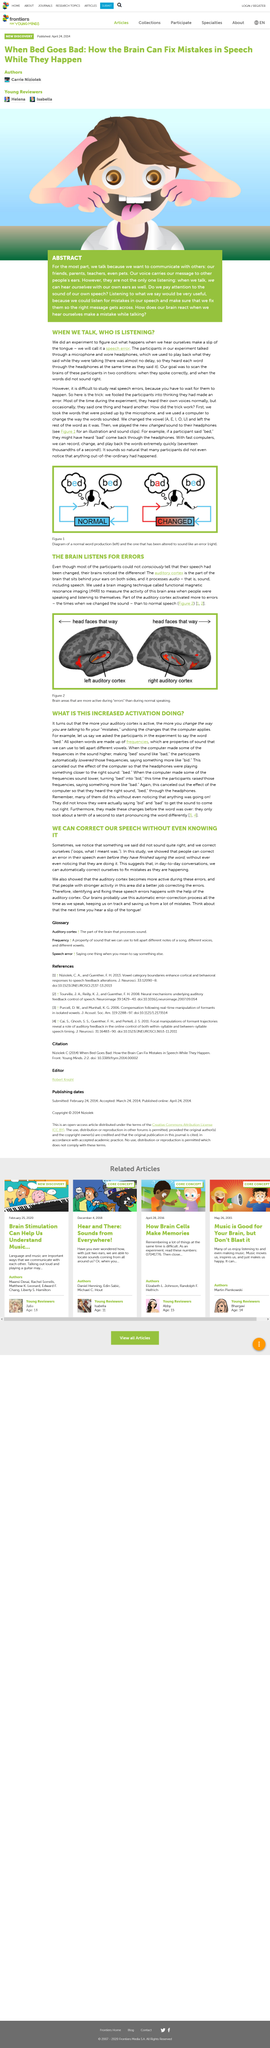Specify some key components in this picture. The title of this article is 'WE CAN CORRECT OUR SPEECH WITHOUT EVEN KNOWING IT.' The color of the boy's eyes in the abstract article is brown. The auditory cortex is discussed in the second paragraph of the article. The brain actively listens for errors and the auditory cortex is particularly active when errors occur. The goal of the experiment was to scan the brains of participants in two conditions: when they spoke correctly and when the words did not sound right. 